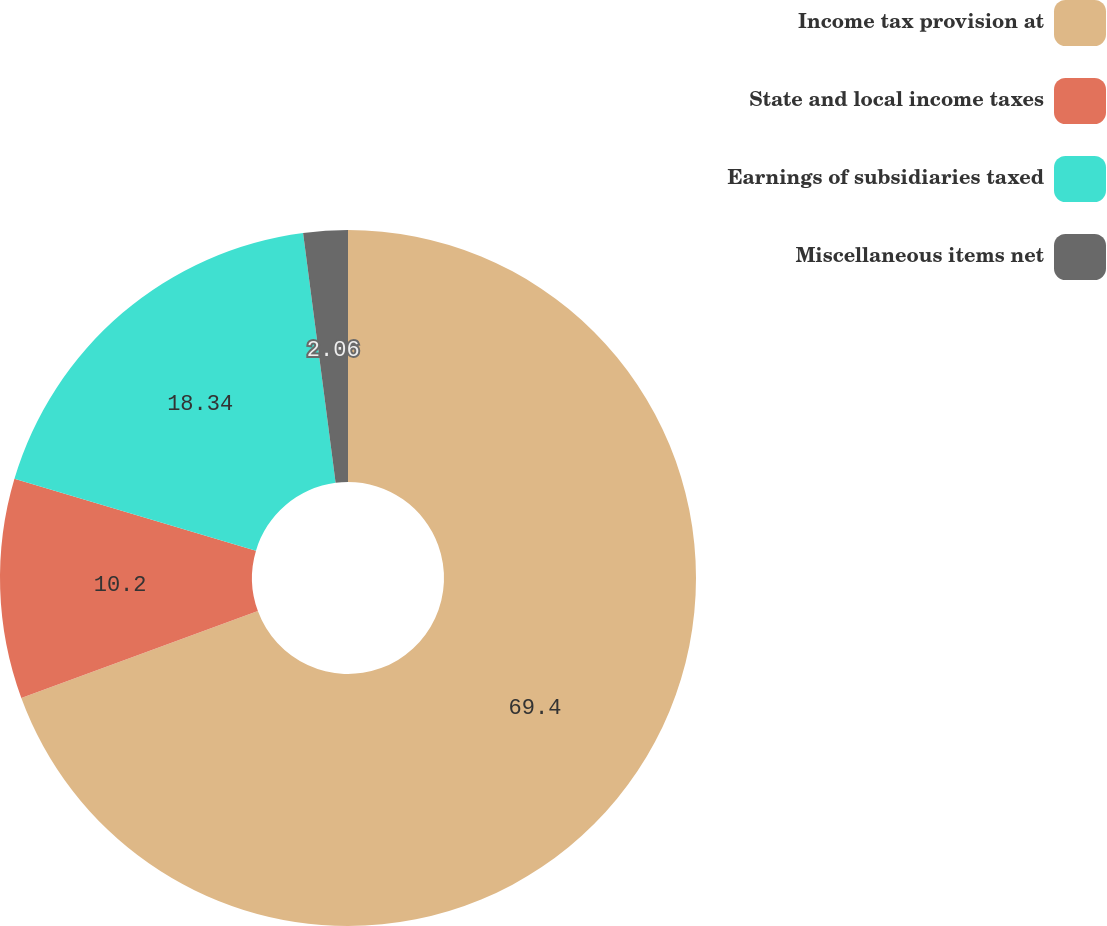Convert chart. <chart><loc_0><loc_0><loc_500><loc_500><pie_chart><fcel>Income tax provision at<fcel>State and local income taxes<fcel>Earnings of subsidiaries taxed<fcel>Miscellaneous items net<nl><fcel>69.4%<fcel>10.2%<fcel>18.34%<fcel>2.06%<nl></chart> 